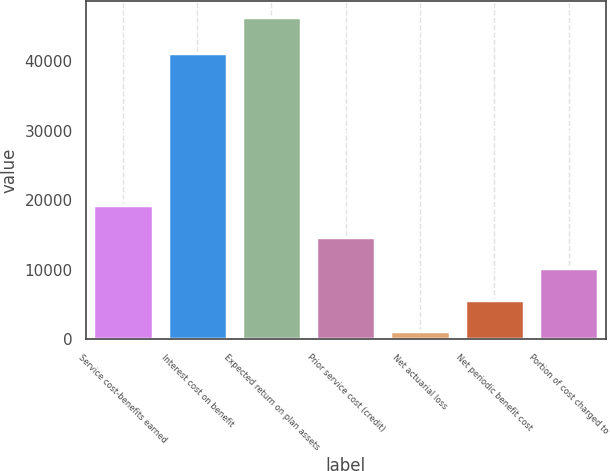<chart> <loc_0><loc_0><loc_500><loc_500><bar_chart><fcel>Service cost-benefits earned<fcel>Interest cost on benefit<fcel>Expected return on plan assets<fcel>Prior service cost (credit)<fcel>Net actuarial loss<fcel>Net periodic benefit cost<fcel>Portion of cost charged to<nl><fcel>19265<fcel>41243<fcel>46400<fcel>14742.5<fcel>1175<fcel>5697.5<fcel>10220<nl></chart> 